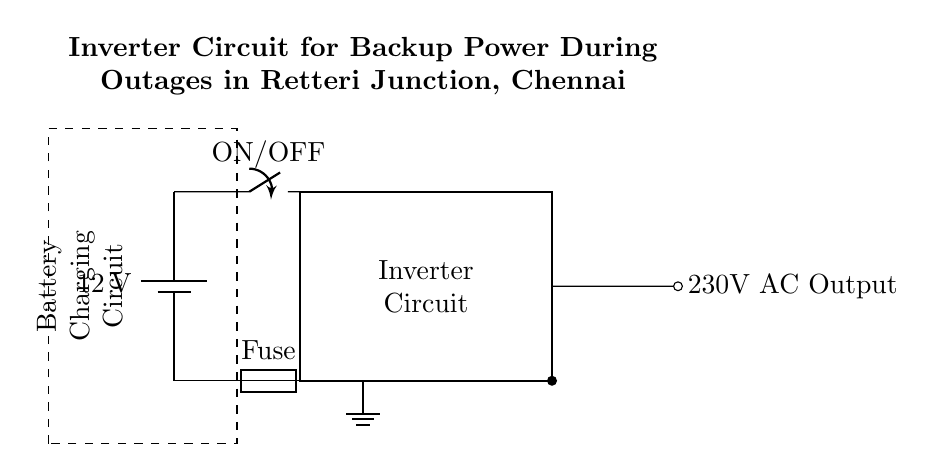What is the voltage of the battery? The circuit diagram indicates that the battery voltage is labeled as 12 volts, which is directly shown in the diagram.
Answer: 12 volts What is the function of the fuse in the circuit? The fuse serves as a safety component that protects the circuit from excessive current by breaking the connection if the current exceeds a certain limit, preventing damage to the components.
Answer: Protection What type of output does the inverter provide? The diagram specifically shows that the output from the inverter is 230 volts AC, as noted in the output label.
Answer: 230 volts AC How is the inverter activated? The inverter is activated by the ON/OFF switch connected from the battery, which controls the flow of electricity to the inverter circuit when flipped to the ON position.
Answer: ON/OFF switch What components are included in the battery charging circuit? The battery charging circuit, which is indicated as a dashed rectangle, typically includes components that manage charging but isn’t detailed in the diagram; it pairs with the battery as an essential part of the inverter setup.
Answer: Charging components What is the purpose of the inverter circuit in this setup? The purpose of the inverter circuit is to convert the DC power from the battery into AC power suitable for household appliances, particularly during outages, allowing for continued operation of high power devices.
Answer: Power conversion 